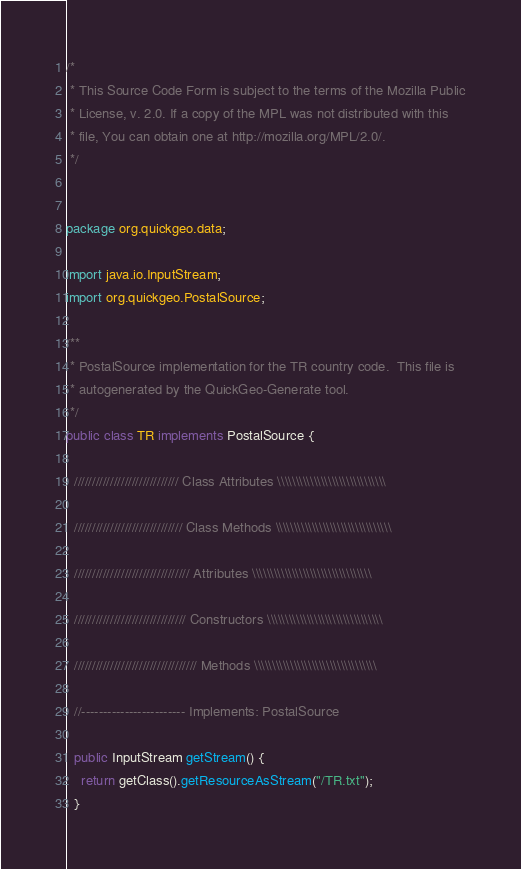<code> <loc_0><loc_0><loc_500><loc_500><_Java_>/*
 * This Source Code Form is subject to the terms of the Mozilla Public
 * License, v. 2.0. If a copy of the MPL was not distributed with this
 * file, You can obtain one at http://mozilla.org/MPL/2.0/. 
 */


package org.quickgeo.data;

import java.io.InputStream;
import org.quickgeo.PostalSource;

/**
 * PostalSource implementation for the TR country code.  This file is
 * autogenerated by the QuickGeo-Generate tool.
 */
public class TR implements PostalSource {
  
  ///////////////////////////// Class Attributes \\\\\\\\\\\\\\\\\\\\\\\\\\\\\\
  
  ////////////////////////////// Class Methods \\\\\\\\\\\\\\\\\\\\\\\\\\\\\\\\
  
  //////////////////////////////// Attributes \\\\\\\\\\\\\\\\\\\\\\\\\\\\\\\\\
  
  /////////////////////////////// Constructors \\\\\\\\\\\\\\\\\\\\\\\\\\\\\\\\  
  
  ////////////////////////////////// Methods \\\\\\\\\\\\\\\\\\\\\\\\\\\\\\\\\\
  
  //------------------------ Implements: PostalSource
  
  public InputStream getStream() {
    return getClass().getResourceAsStream("/TR.txt");
  }</code> 